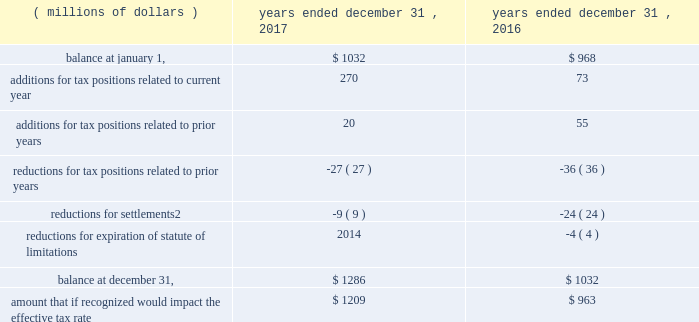82 | 2017 form 10-k a reconciliation of the beginning and ending amount of gross unrecognized tax benefits for uncertain tax positions , including positions impacting only the timing of tax benefits , follows .
Reconciliation of unrecognized tax benefits:1 years a0ended a0december a031 .
1 foreign currency impacts are included within each line as applicable .
2 includes cash payment or other reduction of assets to settle liability .
We classify interest and penalties on income taxes as a component of the provision for income taxes .
We recognized a net provision for interest and penalties of $ 38 million , $ 34 million and $ 20 million during the years ended december 31 , 2017 , 2016 and 2015 , respectively .
The total amount of interest and penalties accrued was $ 157 million and $ 120 million as of december a031 , 2017 and 2016 , respectively .
On january 31 , 2018 , we received a revenue agent 2019s report from the irs indicating the end of the field examination of our u.s .
Income tax returns for 2010 to 2012 .
In the audits of 2007 to 2012 including the impact of a loss carryback to 2005 , the irs has proposed to tax in the united states profits earned from certain parts transactions by csarl , based on the irs examination team 2019s application of the 201csubstance-over-form 201d or 201cassignment-of-income 201d judicial doctrines .
We are vigorously contesting the proposed increases to tax and penalties for these years of approximately $ 2.3 billion .
We believe that the relevant transactions complied with applicable tax laws and did not violate judicial doctrines .
We have filed u.s .
Income tax returns on this same basis for years after 2012 .
Based on the information currently available , we do not anticipate a significant increase or decrease to our unrecognized tax benefits for this matter within the next 12 months .
We currently believe the ultimate disposition of this matter will not have a material adverse effect on our consolidated financial position , liquidity or results of operations .
With the exception of a loss carryback to 2005 , tax years prior to 2007 are generally no longer subject to u.s .
Tax assessment .
In our major non-u.s .
Jurisdictions including australia , brazil , china , germany , japan , mexico , switzerland , singapore and the u.k. , tax years are typically subject to examination for three to ten years .
Due to the uncertainty related to the timing and potential outcome of audits , we cannot estimate the range of reasonably possible change in unrecognized tax benefits in the next 12 months. .
Assuming the same rate of change as in 2017 , what would the 2018 total amount of interest and penalties accrued equal in millions? 
Computations: ((157 / 120) * 157)
Answer: 205.40833. 